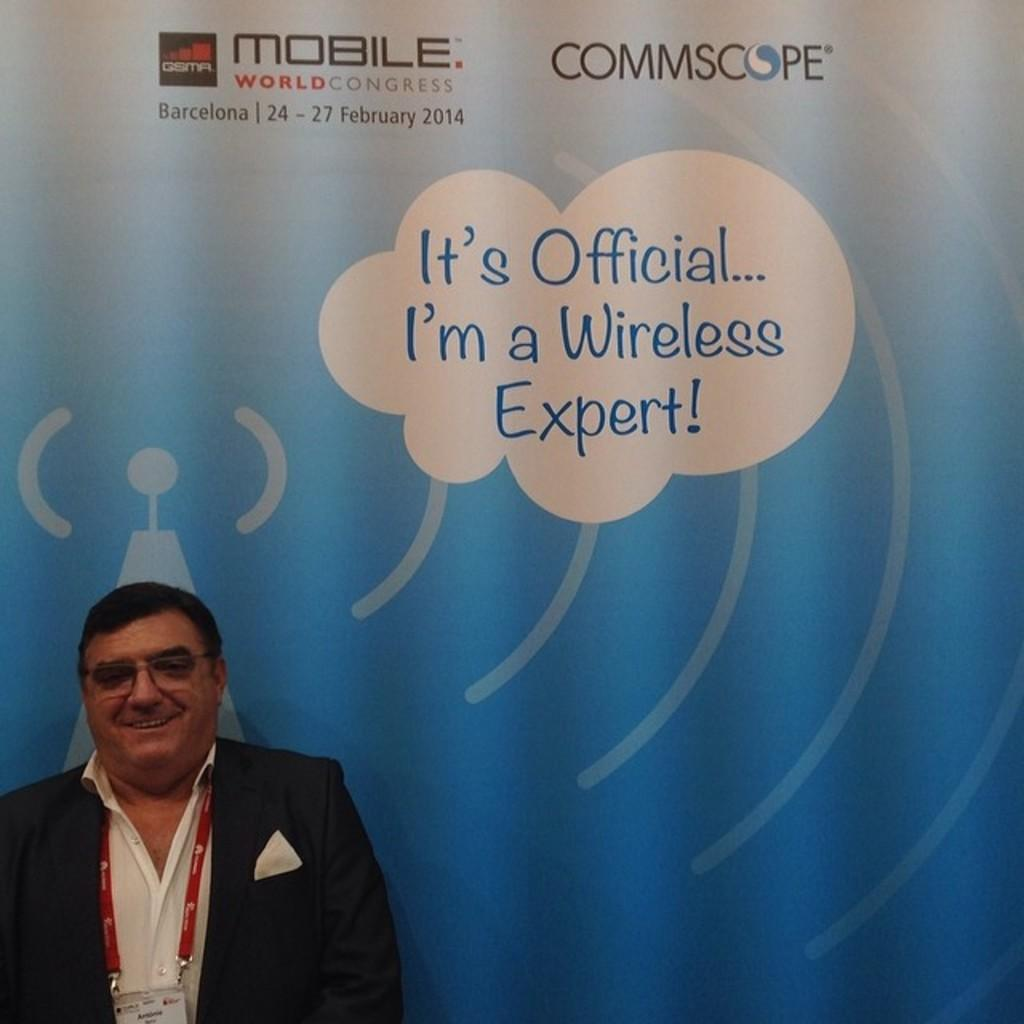<image>
Give a short and clear explanation of the subsequent image. A man stands next to caption which states that he's "a wireless expert". 